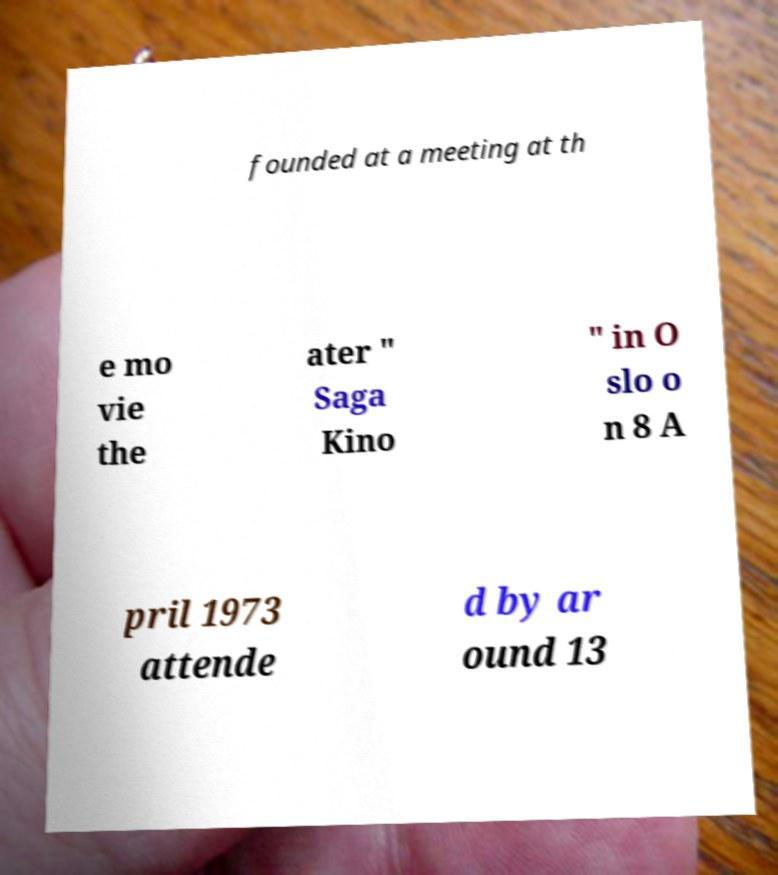What messages or text are displayed in this image? I need them in a readable, typed format. founded at a meeting at th e mo vie the ater " Saga Kino " in O slo o n 8 A pril 1973 attende d by ar ound 13 